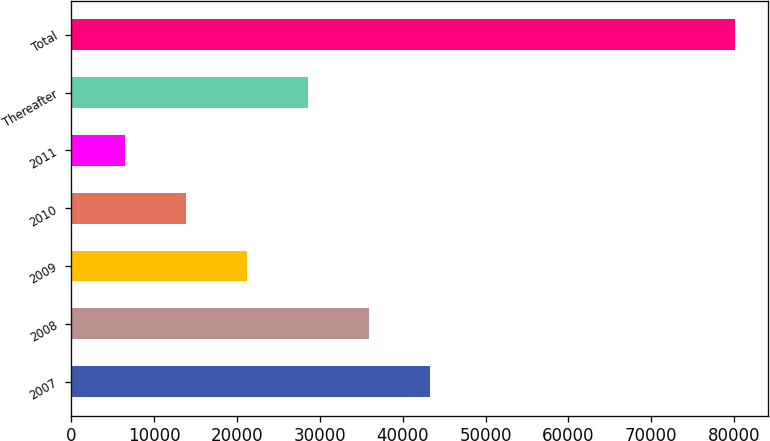Convert chart to OTSL. <chart><loc_0><loc_0><loc_500><loc_500><bar_chart><fcel>2007<fcel>2008<fcel>2009<fcel>2010<fcel>2011<fcel>Thereafter<fcel>Total<nl><fcel>43294.5<fcel>35938.2<fcel>21225.6<fcel>13869.3<fcel>6513<fcel>28581.9<fcel>80076<nl></chart> 